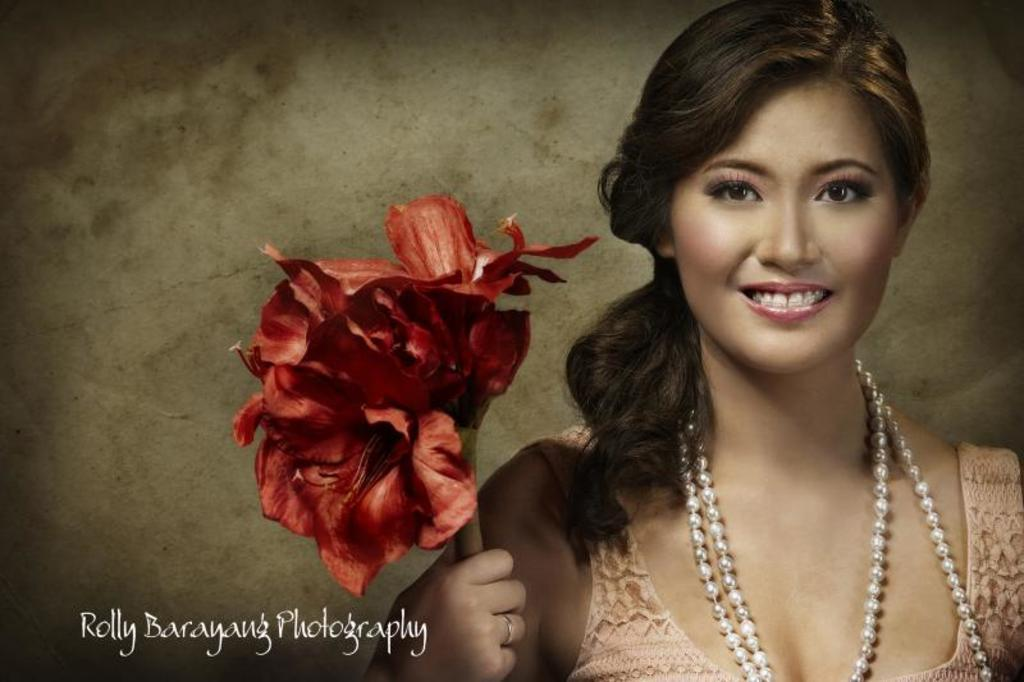Who is the main subject in the image? There is a woman in the image. What is the woman holding in the image? The woman is holding a red flower. Can you describe any accessories the woman is wearing? The woman is wearing a pearl necklace. Is there any text or marking at the bottom of the image? Yes, there is a watermark at the bottom of the image. What type of invention can be seen in the background of the image? There is no invention present in the image; it features a woman holding a red flower and wearing a pearl necklace. 